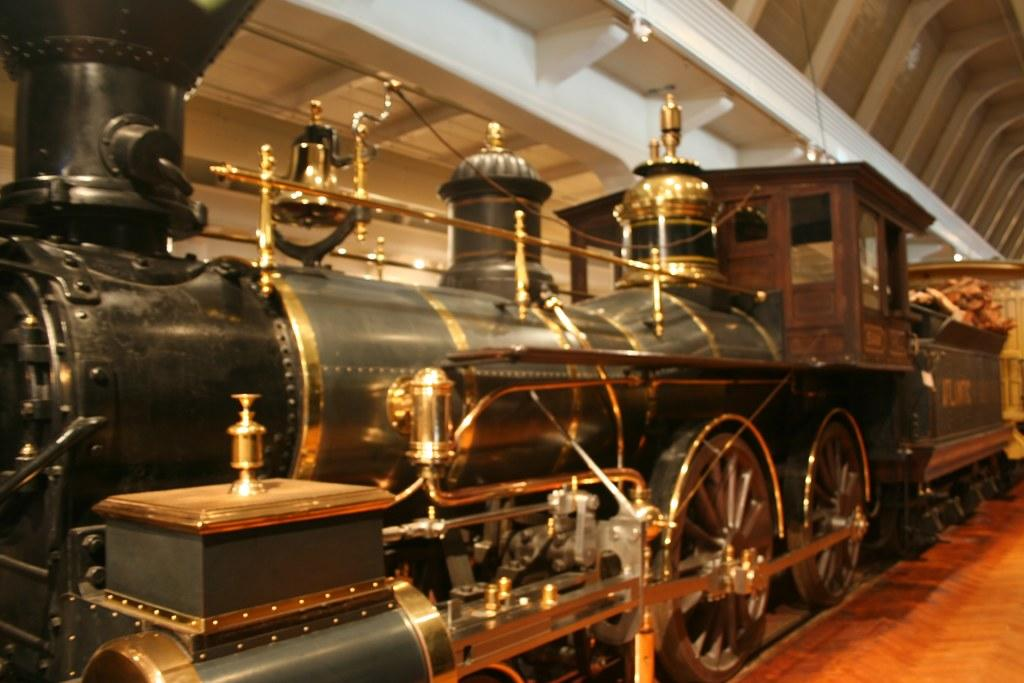What is the main subject of the image? The main subject of the image is a train. Can you describe the train's location in the image? The train is under a roof in the image. What type of cap is the train wearing during its journey in the image? There is no cap present on the train in the image, nor is there a journey depicted. 